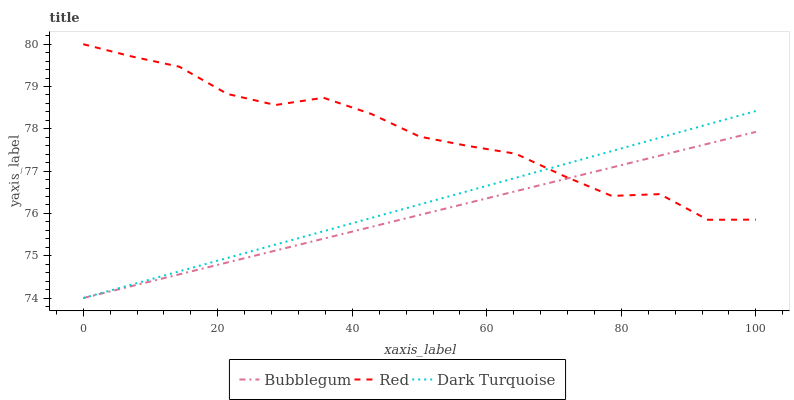Does Bubblegum have the minimum area under the curve?
Answer yes or no. Yes. Does Red have the maximum area under the curve?
Answer yes or no. Yes. Does Red have the minimum area under the curve?
Answer yes or no. No. Does Bubblegum have the maximum area under the curve?
Answer yes or no. No. Is Dark Turquoise the smoothest?
Answer yes or no. Yes. Is Red the roughest?
Answer yes or no. Yes. Is Bubblegum the smoothest?
Answer yes or no. No. Is Bubblegum the roughest?
Answer yes or no. No. Does Dark Turquoise have the lowest value?
Answer yes or no. Yes. Does Red have the lowest value?
Answer yes or no. No. Does Red have the highest value?
Answer yes or no. Yes. Does Bubblegum have the highest value?
Answer yes or no. No. Does Bubblegum intersect Red?
Answer yes or no. Yes. Is Bubblegum less than Red?
Answer yes or no. No. Is Bubblegum greater than Red?
Answer yes or no. No. 